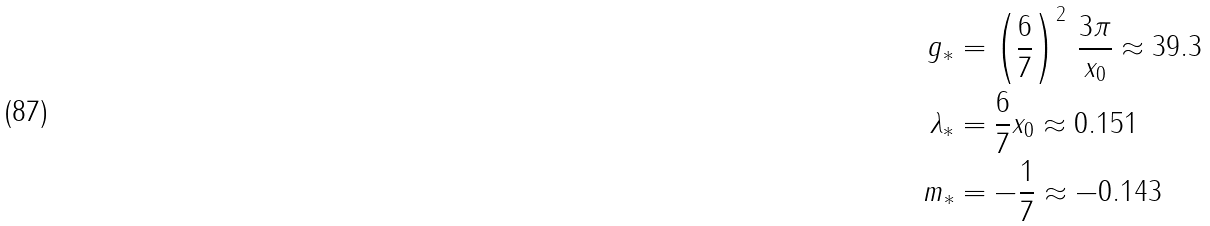<formula> <loc_0><loc_0><loc_500><loc_500>g _ { * } & = \left ( \frac { 6 } { 7 } \right ) ^ { 2 } \, \frac { 3 \pi } { x _ { 0 } } \approx 3 9 . 3 \\ \lambda _ { * } & = \frac { 6 } { 7 } x _ { 0 } \approx 0 . 1 5 1 \\ m _ { * } & = - \frac { 1 } { 7 } \approx - 0 . 1 4 3</formula> 